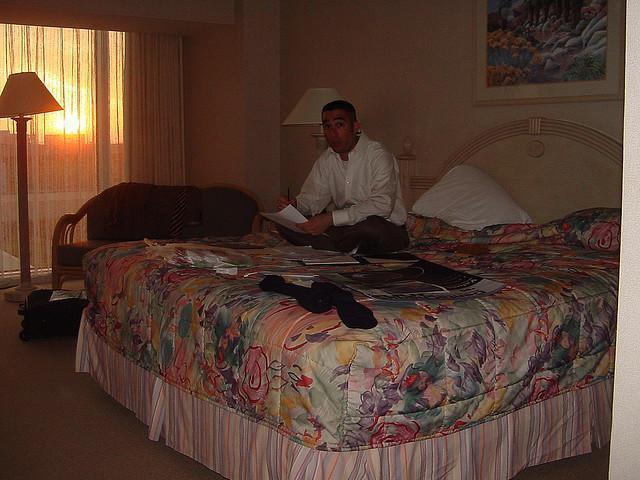How many people in the picture?
Give a very brief answer. 1. How many ovens in this image have a window on their door?
Give a very brief answer. 0. 